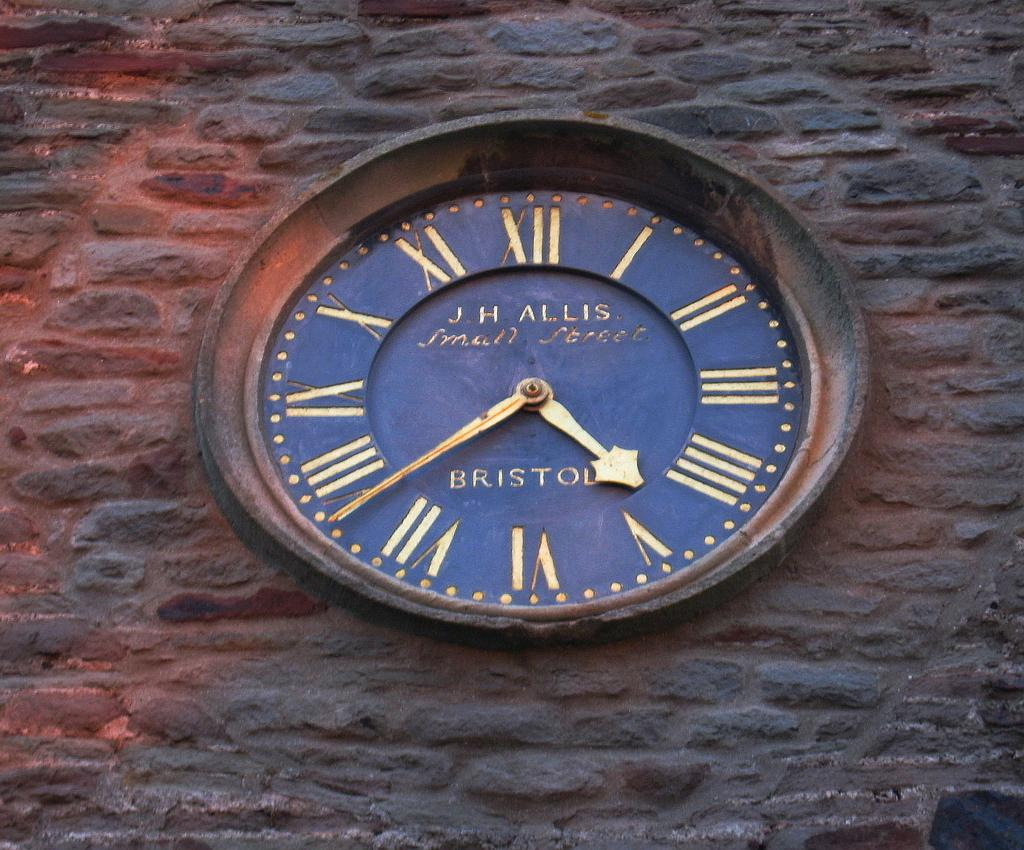<image>
Relay a brief, clear account of the picture shown. a clock that says Bristol on it with arrows 